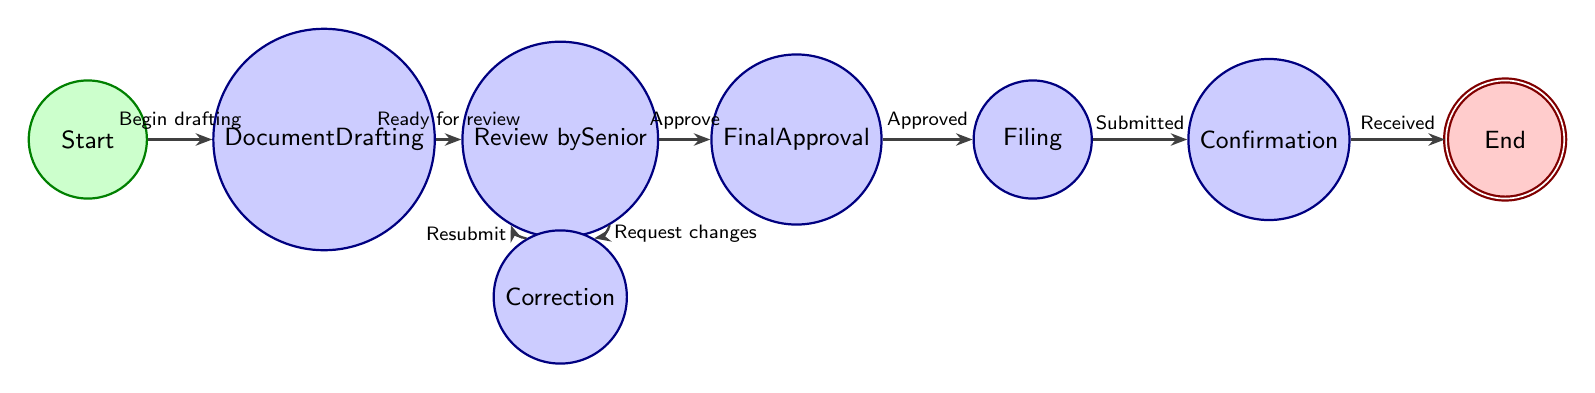What is the initial state of the document submission process? The initial state is labeled as "Start" in the diagram, indicating the beginning of the document submission.
Answer: Start How many states are there in the diagram? By counting the distinct states shown in the diagram—Start, Document Drafting, Review by Senior, Correction, Final Approval, Filing, Confirmation, and End—there are a total of 8 states.
Answer: 8 What is the transition condition from 'Final Approval' to 'Filing'? The condition for transitioning from 'Final Approval' to 'Filing' is labeled as "Document receives final approval," indicating the need for prior approval before filing.
Answer: Document receives final approval Which state comes after 'Confirmation'? Following 'Confirmation,' the diagram indicates the next state as 'End,' which signifies the completion of the process.
Answer: End What happens when the Senior attorney requests changes? When the Senior attorney requests changes, the process transitions from 'Review by Senior' to 'Correction,' indicating that modifications to the document are required.
Answer: Correction Which state requires the document to be submitted to the court clerk? The label "Submitting the document to the court clerk" indicates that the 'Filing' state is where this action takes place as part of the document submission process.
Answer: Filing What is the condition to move from 'Correction' back to 'Review by Senior'? The transition condition from 'Correction' back to 'Review by Senior' is labeled as "Corrections made and resubmitted for review," which indicates that once corrections are made, it goes back for further evaluation.
Answer: Corrections made and resubmitted for review How many transitions are there in the diagram? By examining the diagram, the transitions are counted as follows: Start to Document Drafting, Document Drafting to Review by Senior, Review by Senior to Correction, Correction to Review by Senior, Review by Senior to Final Approval, Final Approval to Filing, Filing to Confirmation, and Confirmation to End, totaling 8 transitions.
Answer: 8 